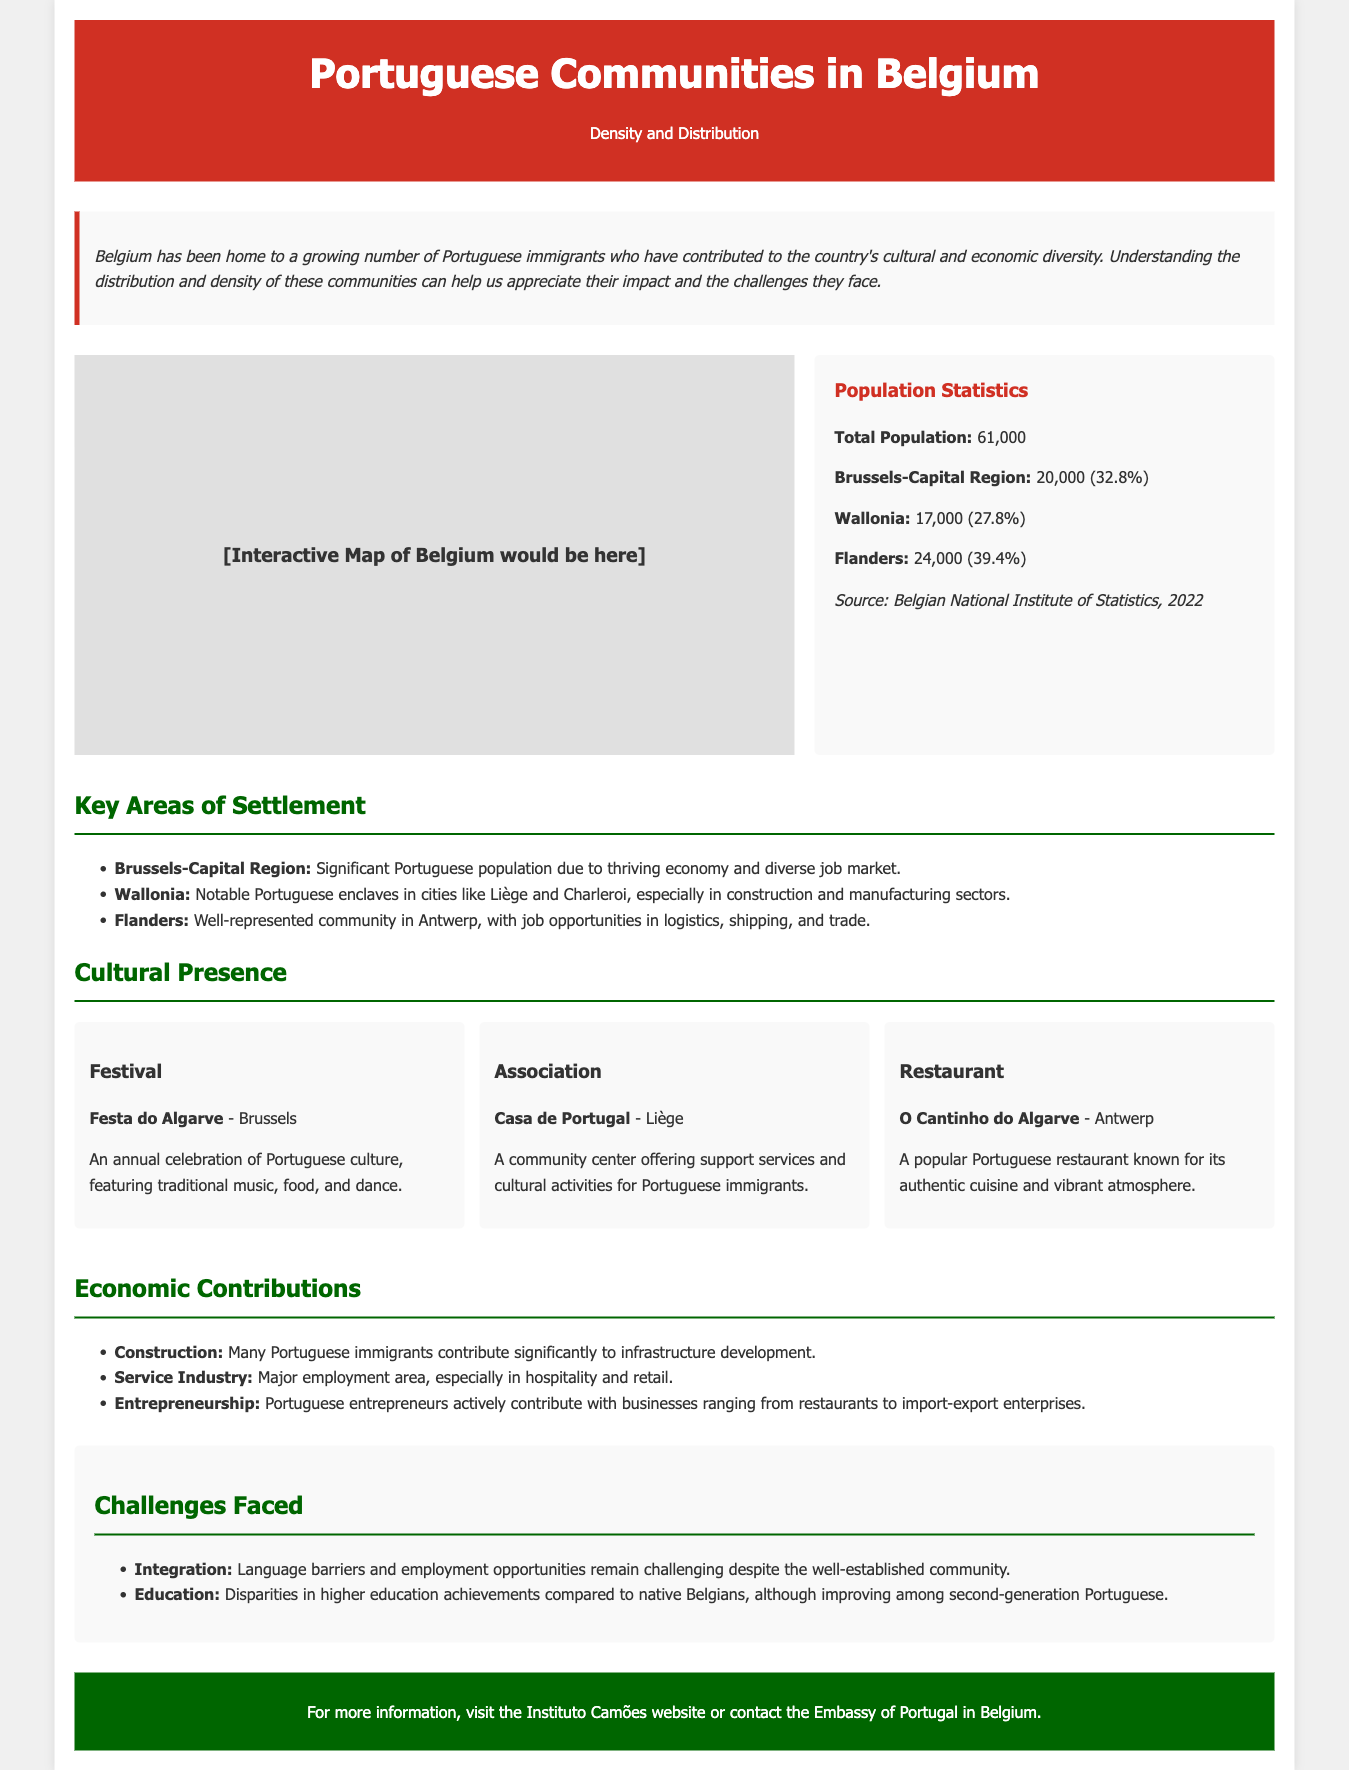What is the total population of Portuguese communities in Belgium? The total population of Portuguese communities in Belgium is mentioned in the document as 61,000.
Answer: 61,000 What percentage of the Portuguese population lives in the Brussels-Capital Region? The document states that 20,000 Portuguese individuals live in the Brussels-Capital Region, which is 32.8% of the total population.
Answer: 32.8% Name one city in Wallonia with notable Portuguese enclaves. The text mentions Liège and Charleroi as cities in Wallonia with notable Portuguese enclaves.
Answer: Liège What is the name of the popular Portuguese restaurant in Antwerp? The document lists "O Cantinho do Algarve" as a well-known Portuguese restaurant in Antwerp.
Answer: O Cantinho do Algarve What is one economic contribution of Portuguese immigrants mentioned in the document? The document states that many Portuguese immigrants contribute significantly to the construction sector.
Answer: Construction Which festival celebrating Portuguese culture takes place in Brussels? The document mentions the "Festa do Algarve" as an annual celebration of Portuguese culture in Brussels.
Answer: Festa do Algarve What challenges are faced by the Portuguese community in Belgium? The document highlights integration issues due to language barriers as one of the challenges faced by the community.
Answer: Integration What is the purpose of the "Casa de Portugal" in Liège? The document describes the "Casa de Portugal" as a community center that offers support services and cultural activities for Portuguese immigrants.
Answer: Support services How does the document categorize the regions where the Portuguese community is located? The document categorizes the regions as Brussels-Capital Region, Wallonia, and Flanders.
Answer: Brussels-Capital Region, Wallonia, Flanders 